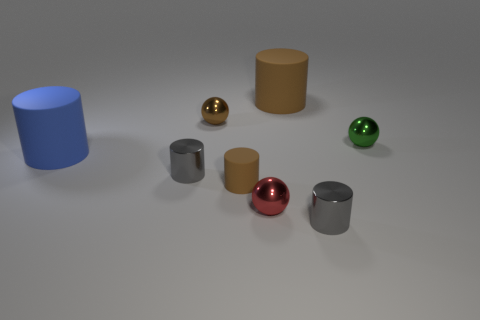There is a tiny red thing; does it have the same shape as the gray metallic object in front of the tiny rubber cylinder?
Keep it short and to the point. No. What is the material of the small green sphere?
Keep it short and to the point. Metal. The large object that is in front of the tiny brown object behind the small gray object that is behind the red metal sphere is what color?
Your answer should be very brief. Blue. There is a large brown object that is the same shape as the blue rubber thing; what is its material?
Provide a short and direct response. Rubber. How many cyan matte blocks are the same size as the brown ball?
Offer a very short reply. 0. What number of tiny metal balls are there?
Ensure brevity in your answer.  3. Does the tiny green thing have the same material as the gray thing in front of the small red shiny ball?
Give a very brief answer. Yes. How many gray objects are either shiny cylinders or matte objects?
Offer a very short reply. 2. The red thing that is made of the same material as the small green ball is what size?
Offer a very short reply. Small. How many other red metal things have the same shape as the tiny red thing?
Offer a very short reply. 0. 